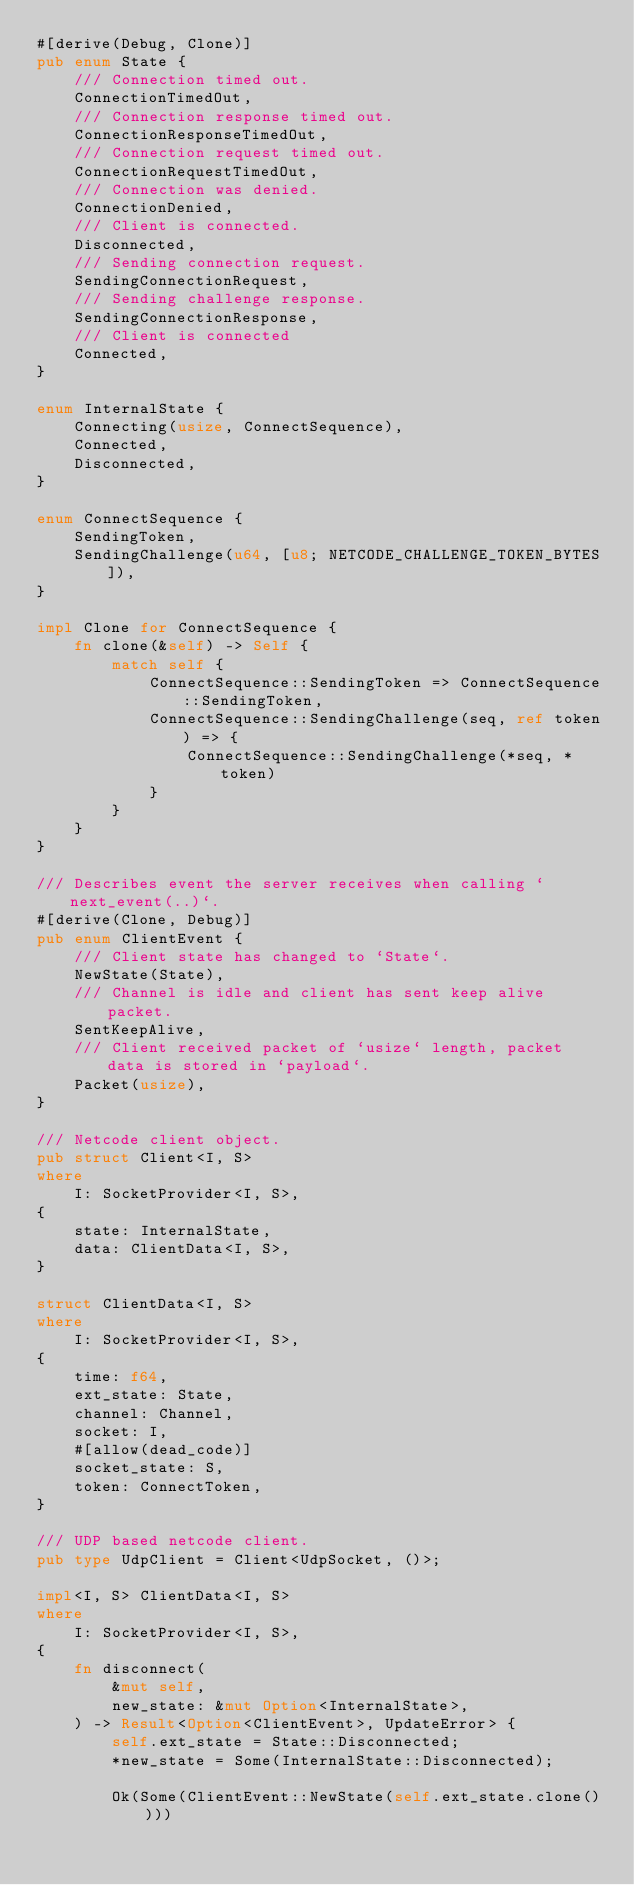<code> <loc_0><loc_0><loc_500><loc_500><_Rust_>#[derive(Debug, Clone)]
pub enum State {
    /// Connection timed out.
    ConnectionTimedOut,
    /// Connection response timed out.
    ConnectionResponseTimedOut,
    /// Connection request timed out.
    ConnectionRequestTimedOut,
    /// Connection was denied.
    ConnectionDenied,
    /// Client is connected.
    Disconnected,
    /// Sending connection request.
    SendingConnectionRequest,
    /// Sending challenge response.
    SendingConnectionResponse,
    /// Client is connected
    Connected,
}

enum InternalState {
    Connecting(usize, ConnectSequence),
    Connected,
    Disconnected,
}

enum ConnectSequence {
    SendingToken,
    SendingChallenge(u64, [u8; NETCODE_CHALLENGE_TOKEN_BYTES]),
}

impl Clone for ConnectSequence {
    fn clone(&self) -> Self {
        match self {
            ConnectSequence::SendingToken => ConnectSequence::SendingToken,
            ConnectSequence::SendingChallenge(seq, ref token) => {
                ConnectSequence::SendingChallenge(*seq, *token)
            }
        }
    }
}

/// Describes event the server receives when calling `next_event(..)`.
#[derive(Clone, Debug)]
pub enum ClientEvent {
    /// Client state has changed to `State`.
    NewState(State),
    /// Channel is idle and client has sent keep alive packet.
    SentKeepAlive,
    /// Client received packet of `usize` length, packet data is stored in `payload`.
    Packet(usize),
}

/// Netcode client object.
pub struct Client<I, S>
where
    I: SocketProvider<I, S>,
{
    state: InternalState,
    data: ClientData<I, S>,
}

struct ClientData<I, S>
where
    I: SocketProvider<I, S>,
{
    time: f64,
    ext_state: State,
    channel: Channel,
    socket: I,
    #[allow(dead_code)]
    socket_state: S,
    token: ConnectToken,
}

/// UDP based netcode client.
pub type UdpClient = Client<UdpSocket, ()>;

impl<I, S> ClientData<I, S>
where
    I: SocketProvider<I, S>,
{
    fn disconnect(
        &mut self,
        new_state: &mut Option<InternalState>,
    ) -> Result<Option<ClientEvent>, UpdateError> {
        self.ext_state = State::Disconnected;
        *new_state = Some(InternalState::Disconnected);

        Ok(Some(ClientEvent::NewState(self.ext_state.clone())))</code> 